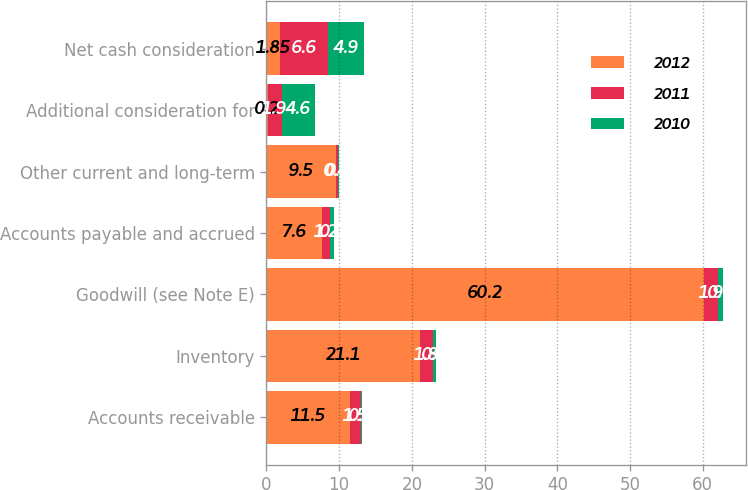Convert chart. <chart><loc_0><loc_0><loc_500><loc_500><stacked_bar_chart><ecel><fcel>Accounts receivable<fcel>Inventory<fcel>Goodwill (see Note E)<fcel>Accounts payable and accrued<fcel>Other current and long-term<fcel>Additional consideration for<fcel>Net cash consideration<nl><fcel>2012<fcel>11.5<fcel>21.1<fcel>60.2<fcel>7.6<fcel>9.5<fcel>0.2<fcel>1.85<nl><fcel>2011<fcel>1.5<fcel>1.8<fcel>1.9<fcel>1.2<fcel>0.4<fcel>1.9<fcel>6.6<nl><fcel>2010<fcel>0.1<fcel>0.4<fcel>0.7<fcel>0.5<fcel>0.1<fcel>4.6<fcel>4.9<nl></chart> 